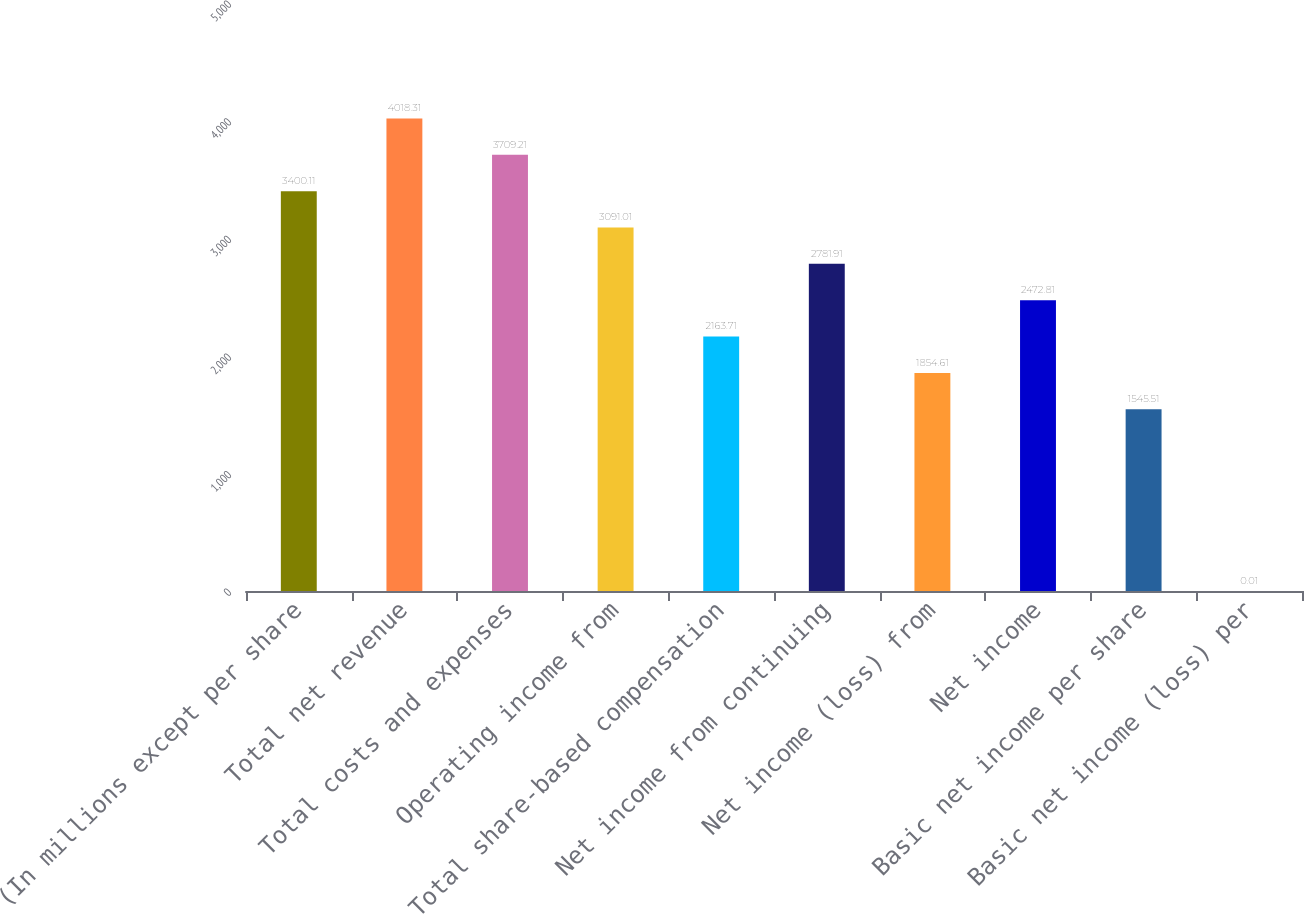<chart> <loc_0><loc_0><loc_500><loc_500><bar_chart><fcel>(In millions except per share<fcel>Total net revenue<fcel>Total costs and expenses<fcel>Operating income from<fcel>Total share-based compensation<fcel>Net income from continuing<fcel>Net income (loss) from<fcel>Net income<fcel>Basic net income per share<fcel>Basic net income (loss) per<nl><fcel>3400.11<fcel>4018.31<fcel>3709.21<fcel>3091.01<fcel>2163.71<fcel>2781.91<fcel>1854.61<fcel>2472.81<fcel>1545.51<fcel>0.01<nl></chart> 